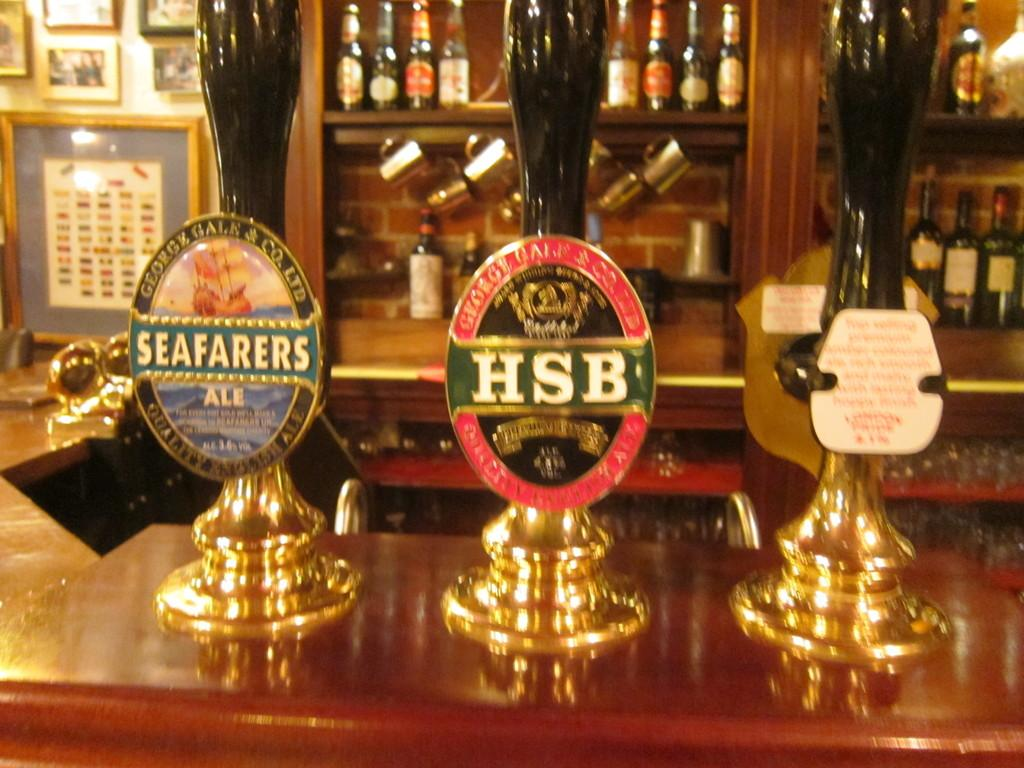<image>
Render a clear and concise summary of the photo. Three beer taps at a bar with the middle one named "HSB". 